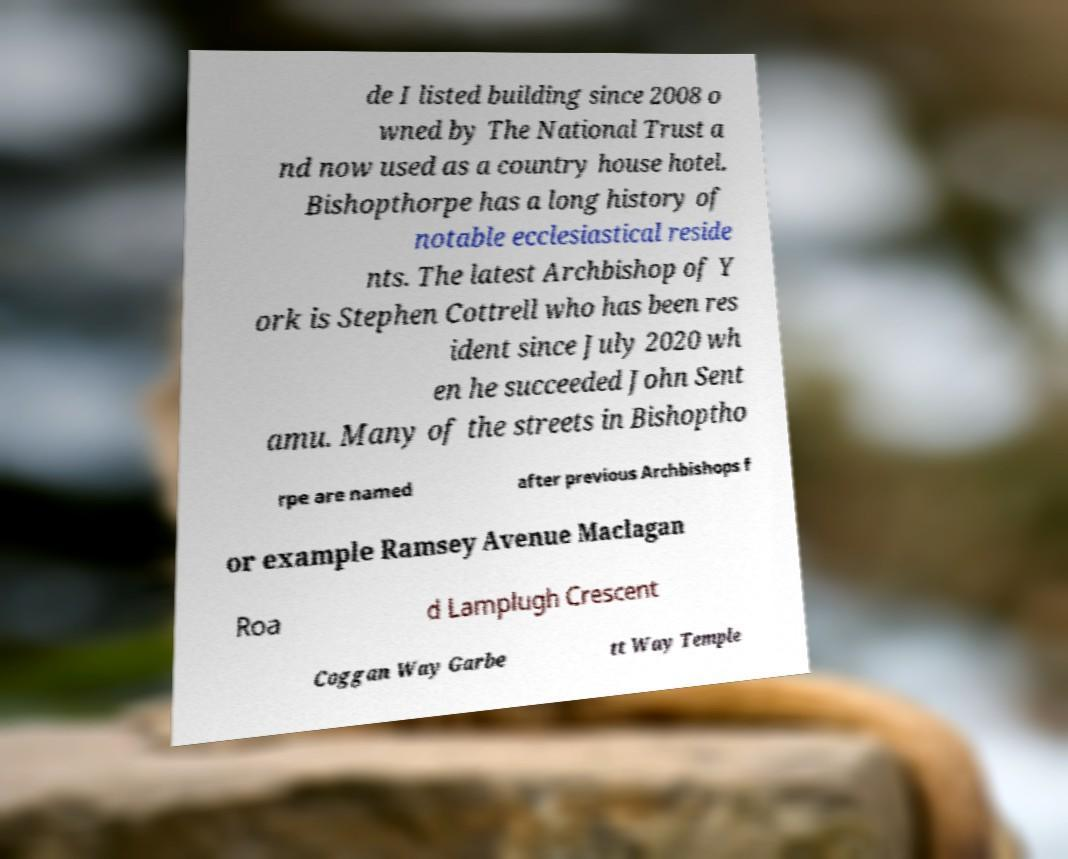For documentation purposes, I need the text within this image transcribed. Could you provide that? de I listed building since 2008 o wned by The National Trust a nd now used as a country house hotel. Bishopthorpe has a long history of notable ecclesiastical reside nts. The latest Archbishop of Y ork is Stephen Cottrell who has been res ident since July 2020 wh en he succeeded John Sent amu. Many of the streets in Bishoptho rpe are named after previous Archbishops f or example Ramsey Avenue Maclagan Roa d Lamplugh Crescent Coggan Way Garbe tt Way Temple 